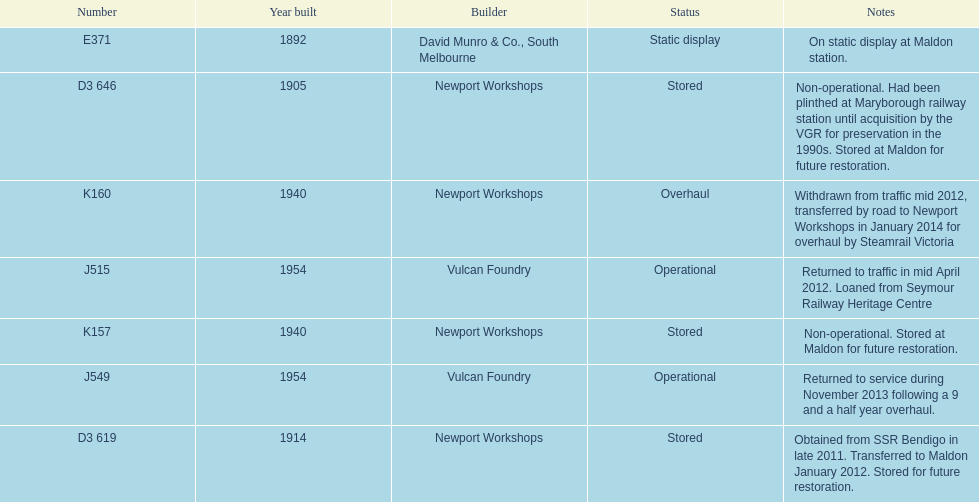Which are the only trains still in service? J515, J549. 